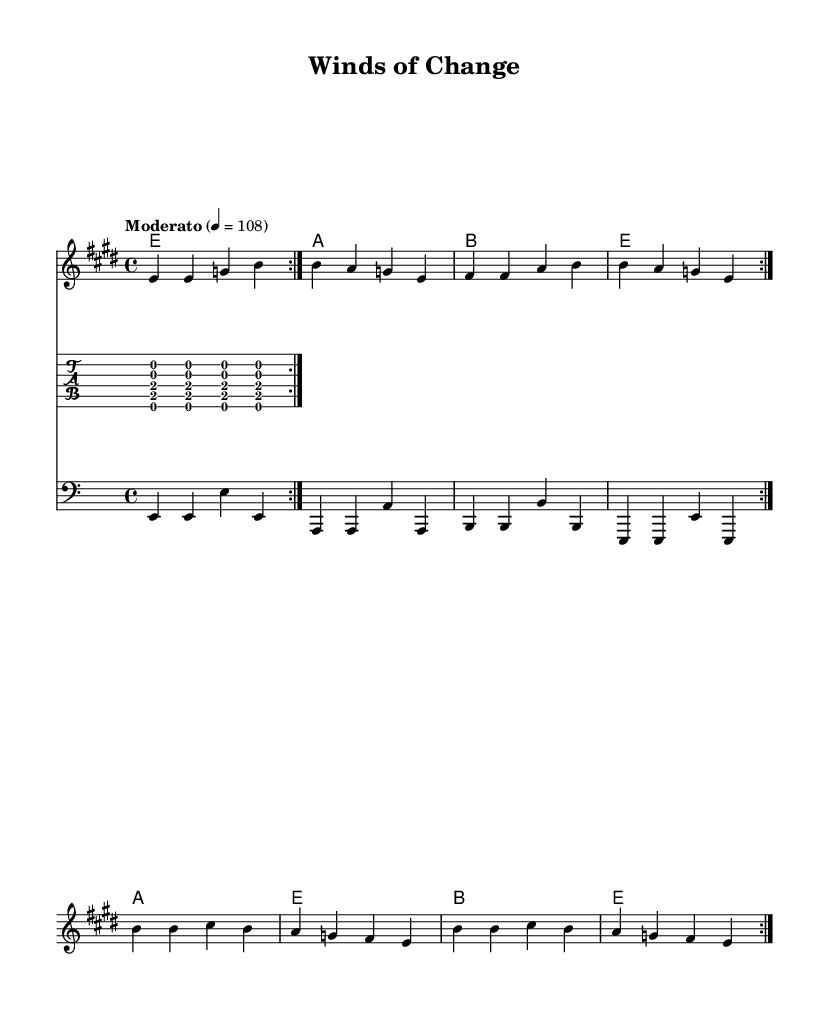What is the key signature of this music? The key signature is E major, which contains four sharps (F#, C#, G#, D#). This can be determined from the global settings where the key is specified as "e major."
Answer: E major What is the time signature of this music? The time signature is 4/4, visible in the global settings where it is stated directly. This indicates there are four beats in each measure, and the quarter note gets one beat.
Answer: 4/4 What is the tempo marking of this piece? The tempo marking is "Moderato," which is specified in the global settings alongside the beats per minute (108). This indicates a moderate pace for the music.
Answer: Moderato How many verses are included in the lyrics? The lyrics include one verse followed by a chorus, as indicated by the structure "verseOne" followed by "chorusLyrics." Counting these gives us one verse.
Answer: One What is the chord progression used in the harmonies? The chord progression is E - A - B - E, repeated for each volta. This can be interpreted from the harmonies section detailing the chords played in succession.
Answer: E - A - B - E What is the style characteristic of the guitar riff presented here? The guitar riff is characteristic of classic British rock, employing power chords and a repetitive structure, enhancing the song's driving rhythm prevalent in rock genres of the 60s and 70s. This can be inferred from the use of intervals forming the power chord sound.
Answer: Classic British rock What thematic element does the title suggest about the song's content? The title "Winds of Change" suggests themes of social change and evolution, a prevalent motif in 60s and 70s British rock music that often addressed sociopolitical issues. The title directly implies transformation and progress.
Answer: Social change 